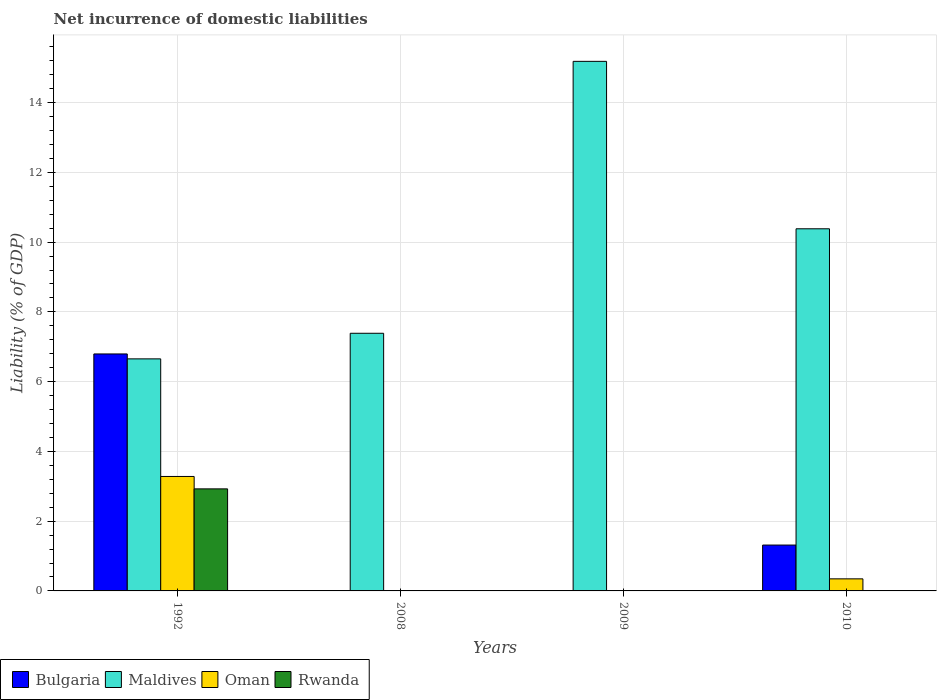What is the net incurrence of domestic liabilities in Oman in 2009?
Provide a short and direct response. 0. Across all years, what is the maximum net incurrence of domestic liabilities in Rwanda?
Provide a short and direct response. 2.93. Across all years, what is the minimum net incurrence of domestic liabilities in Maldives?
Your answer should be compact. 6.65. In which year was the net incurrence of domestic liabilities in Bulgaria maximum?
Make the answer very short. 1992. What is the total net incurrence of domestic liabilities in Maldives in the graph?
Ensure brevity in your answer.  39.6. What is the difference between the net incurrence of domestic liabilities in Maldives in 2008 and that in 2010?
Offer a terse response. -3. What is the difference between the net incurrence of domestic liabilities in Oman in 1992 and the net incurrence of domestic liabilities in Maldives in 2009?
Offer a very short reply. -11.9. What is the average net incurrence of domestic liabilities in Rwanda per year?
Keep it short and to the point. 0.73. In the year 2010, what is the difference between the net incurrence of domestic liabilities in Oman and net incurrence of domestic liabilities in Bulgaria?
Your answer should be compact. -0.97. In how many years, is the net incurrence of domestic liabilities in Maldives greater than 10.4 %?
Give a very brief answer. 1. What is the ratio of the net incurrence of domestic liabilities in Maldives in 1992 to that in 2009?
Provide a short and direct response. 0.44. Is the net incurrence of domestic liabilities in Oman in 1992 less than that in 2010?
Your answer should be compact. No. What is the difference between the highest and the lowest net incurrence of domestic liabilities in Maldives?
Your answer should be very brief. 8.53. In how many years, is the net incurrence of domestic liabilities in Bulgaria greater than the average net incurrence of domestic liabilities in Bulgaria taken over all years?
Provide a short and direct response. 1. Is it the case that in every year, the sum of the net incurrence of domestic liabilities in Rwanda and net incurrence of domestic liabilities in Oman is greater than the sum of net incurrence of domestic liabilities in Bulgaria and net incurrence of domestic liabilities in Maldives?
Your answer should be compact. No. Is it the case that in every year, the sum of the net incurrence of domestic liabilities in Rwanda and net incurrence of domestic liabilities in Bulgaria is greater than the net incurrence of domestic liabilities in Oman?
Provide a succinct answer. No. How many bars are there?
Offer a terse response. 9. Does the graph contain grids?
Provide a short and direct response. Yes. How many legend labels are there?
Ensure brevity in your answer.  4. How are the legend labels stacked?
Keep it short and to the point. Horizontal. What is the title of the graph?
Keep it short and to the point. Net incurrence of domestic liabilities. Does "Korea (Democratic)" appear as one of the legend labels in the graph?
Ensure brevity in your answer.  No. What is the label or title of the X-axis?
Offer a very short reply. Years. What is the label or title of the Y-axis?
Offer a very short reply. Liability (% of GDP). What is the Liability (% of GDP) of Bulgaria in 1992?
Your answer should be very brief. 6.79. What is the Liability (% of GDP) in Maldives in 1992?
Provide a short and direct response. 6.65. What is the Liability (% of GDP) of Oman in 1992?
Make the answer very short. 3.28. What is the Liability (% of GDP) of Rwanda in 1992?
Give a very brief answer. 2.93. What is the Liability (% of GDP) of Maldives in 2008?
Provide a succinct answer. 7.39. What is the Liability (% of GDP) in Bulgaria in 2009?
Offer a terse response. 0. What is the Liability (% of GDP) of Maldives in 2009?
Your response must be concise. 15.18. What is the Liability (% of GDP) in Bulgaria in 2010?
Ensure brevity in your answer.  1.31. What is the Liability (% of GDP) in Maldives in 2010?
Your answer should be very brief. 10.38. What is the Liability (% of GDP) in Oman in 2010?
Ensure brevity in your answer.  0.35. What is the Liability (% of GDP) of Rwanda in 2010?
Keep it short and to the point. 0. Across all years, what is the maximum Liability (% of GDP) in Bulgaria?
Give a very brief answer. 6.79. Across all years, what is the maximum Liability (% of GDP) in Maldives?
Provide a short and direct response. 15.18. Across all years, what is the maximum Liability (% of GDP) in Oman?
Provide a succinct answer. 3.28. Across all years, what is the maximum Liability (% of GDP) in Rwanda?
Ensure brevity in your answer.  2.93. Across all years, what is the minimum Liability (% of GDP) of Maldives?
Offer a very short reply. 6.65. Across all years, what is the minimum Liability (% of GDP) in Rwanda?
Provide a succinct answer. 0. What is the total Liability (% of GDP) in Bulgaria in the graph?
Ensure brevity in your answer.  8.11. What is the total Liability (% of GDP) of Maldives in the graph?
Make the answer very short. 39.6. What is the total Liability (% of GDP) in Oman in the graph?
Ensure brevity in your answer.  3.63. What is the total Liability (% of GDP) of Rwanda in the graph?
Make the answer very short. 2.93. What is the difference between the Liability (% of GDP) in Maldives in 1992 and that in 2008?
Provide a succinct answer. -0.73. What is the difference between the Liability (% of GDP) in Maldives in 1992 and that in 2009?
Your answer should be very brief. -8.53. What is the difference between the Liability (% of GDP) of Bulgaria in 1992 and that in 2010?
Your response must be concise. 5.48. What is the difference between the Liability (% of GDP) in Maldives in 1992 and that in 2010?
Offer a terse response. -3.73. What is the difference between the Liability (% of GDP) in Oman in 1992 and that in 2010?
Keep it short and to the point. 2.94. What is the difference between the Liability (% of GDP) of Maldives in 2008 and that in 2009?
Provide a short and direct response. -7.8. What is the difference between the Liability (% of GDP) in Maldives in 2008 and that in 2010?
Your answer should be compact. -3. What is the difference between the Liability (% of GDP) in Maldives in 2009 and that in 2010?
Your answer should be compact. 4.8. What is the difference between the Liability (% of GDP) of Bulgaria in 1992 and the Liability (% of GDP) of Maldives in 2008?
Offer a terse response. -0.59. What is the difference between the Liability (% of GDP) of Bulgaria in 1992 and the Liability (% of GDP) of Maldives in 2009?
Offer a terse response. -8.39. What is the difference between the Liability (% of GDP) in Bulgaria in 1992 and the Liability (% of GDP) in Maldives in 2010?
Offer a very short reply. -3.59. What is the difference between the Liability (% of GDP) in Bulgaria in 1992 and the Liability (% of GDP) in Oman in 2010?
Provide a succinct answer. 6.45. What is the difference between the Liability (% of GDP) of Maldives in 1992 and the Liability (% of GDP) of Oman in 2010?
Make the answer very short. 6.31. What is the difference between the Liability (% of GDP) in Maldives in 2008 and the Liability (% of GDP) in Oman in 2010?
Offer a terse response. 7.04. What is the difference between the Liability (% of GDP) in Maldives in 2009 and the Liability (% of GDP) in Oman in 2010?
Offer a very short reply. 14.84. What is the average Liability (% of GDP) in Bulgaria per year?
Give a very brief answer. 2.03. What is the average Liability (% of GDP) of Maldives per year?
Keep it short and to the point. 9.9. What is the average Liability (% of GDP) in Oman per year?
Keep it short and to the point. 0.91. What is the average Liability (% of GDP) of Rwanda per year?
Offer a very short reply. 0.73. In the year 1992, what is the difference between the Liability (% of GDP) of Bulgaria and Liability (% of GDP) of Maldives?
Keep it short and to the point. 0.14. In the year 1992, what is the difference between the Liability (% of GDP) in Bulgaria and Liability (% of GDP) in Oman?
Your answer should be very brief. 3.51. In the year 1992, what is the difference between the Liability (% of GDP) in Bulgaria and Liability (% of GDP) in Rwanda?
Your answer should be very brief. 3.87. In the year 1992, what is the difference between the Liability (% of GDP) of Maldives and Liability (% of GDP) of Oman?
Provide a short and direct response. 3.37. In the year 1992, what is the difference between the Liability (% of GDP) of Maldives and Liability (% of GDP) of Rwanda?
Give a very brief answer. 3.73. In the year 1992, what is the difference between the Liability (% of GDP) of Oman and Liability (% of GDP) of Rwanda?
Offer a terse response. 0.36. In the year 2010, what is the difference between the Liability (% of GDP) in Bulgaria and Liability (% of GDP) in Maldives?
Make the answer very short. -9.07. In the year 2010, what is the difference between the Liability (% of GDP) in Bulgaria and Liability (% of GDP) in Oman?
Give a very brief answer. 0.97. In the year 2010, what is the difference between the Liability (% of GDP) in Maldives and Liability (% of GDP) in Oman?
Offer a terse response. 10.04. What is the ratio of the Liability (% of GDP) in Maldives in 1992 to that in 2008?
Make the answer very short. 0.9. What is the ratio of the Liability (% of GDP) of Maldives in 1992 to that in 2009?
Your answer should be compact. 0.44. What is the ratio of the Liability (% of GDP) in Bulgaria in 1992 to that in 2010?
Your response must be concise. 5.17. What is the ratio of the Liability (% of GDP) of Maldives in 1992 to that in 2010?
Provide a succinct answer. 0.64. What is the ratio of the Liability (% of GDP) in Oman in 1992 to that in 2010?
Offer a very short reply. 9.48. What is the ratio of the Liability (% of GDP) in Maldives in 2008 to that in 2009?
Offer a terse response. 0.49. What is the ratio of the Liability (% of GDP) in Maldives in 2008 to that in 2010?
Make the answer very short. 0.71. What is the ratio of the Liability (% of GDP) in Maldives in 2009 to that in 2010?
Offer a very short reply. 1.46. What is the difference between the highest and the second highest Liability (% of GDP) in Maldives?
Give a very brief answer. 4.8. What is the difference between the highest and the lowest Liability (% of GDP) of Bulgaria?
Your answer should be very brief. 6.79. What is the difference between the highest and the lowest Liability (% of GDP) of Maldives?
Provide a succinct answer. 8.53. What is the difference between the highest and the lowest Liability (% of GDP) of Oman?
Provide a succinct answer. 3.28. What is the difference between the highest and the lowest Liability (% of GDP) of Rwanda?
Offer a very short reply. 2.93. 